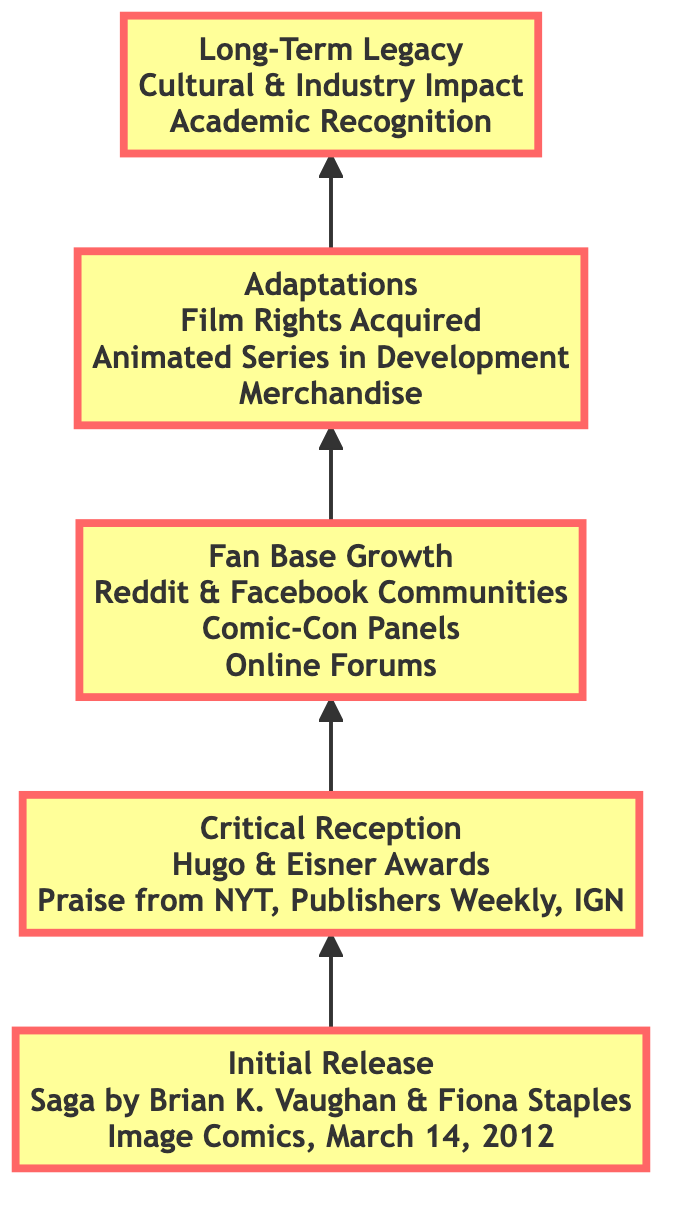What is the title of the graphic novel mentioned in the diagram? The title is found in the first node labeled "Initial Release," which states "Saga" as the graphic novel title.
Answer: Saga Who is the illustrator of the graphic novel? The illustrator's name is also listed in the "Initial Release" node alongside the title, which states "Fiona Staples" as the illustrator.
Answer: Fiona Staples How many awards are mentioned in the "Critical Reception" stage? In the "Critical Reception" node, there are two awards listed: "Hugo Award for Best Graphic Story" and "Eisner Award for Best Continuing Series," thus totaling two awards.
Answer: 2 Which social media platform is mentioned for fan base growth? The "Fan Base Growth" node includes "Reddit" as part of the social media communities.
Answer: Reddit What is the last stage in the diagram? By following the flow of the diagram from bottom to top, the last stage is stated in the top node labeled "Long-Term Legacy."
Answer: Long-Term Legacy How does the graphic novel influence new works according to the "Long-Term Legacy" stage? The "Long-Term Legacy" node mentions "Influence on New Graphic Novels" as one of its cultural impacts, indicating its ability to impact subsequent works in the industry.
Answer: Influence on New Graphic Novels What adaptations are mentioned in the "Adaptations" stage of the diagram? The "Adaptations" node lists two specific adaptations: "Film Rights Acquired" and "Animated Series in Development." Thus, it highlights the media adaptations associated with the graphic novel.
Answer: Film Rights Acquired, Animated Series in Development What was the initial reception of the graphic novel based on major review outlets? The "Critical Reception" node includes "Praise from NYT, Publishers Weekly, IGN," indicating that these review outlets provided favorable evaluations of the graphic novel at its release.
Answer: Praise from NYT, Publishers Weekly, IGN Which conventions are mentioned for fan base growth? The "Fan Base Growth" node lists "San Diego Comic-Con Panels" and "New York Comic Con Signings" as conventions where the graphic novel's fan base expands.
Answer: San Diego Comic-Con Panels, New York Comic Con Signings 